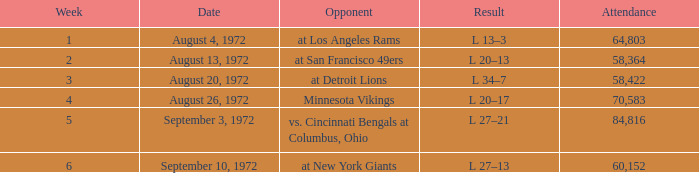How many weeks had an attendance larger than 84,816? 0.0. 